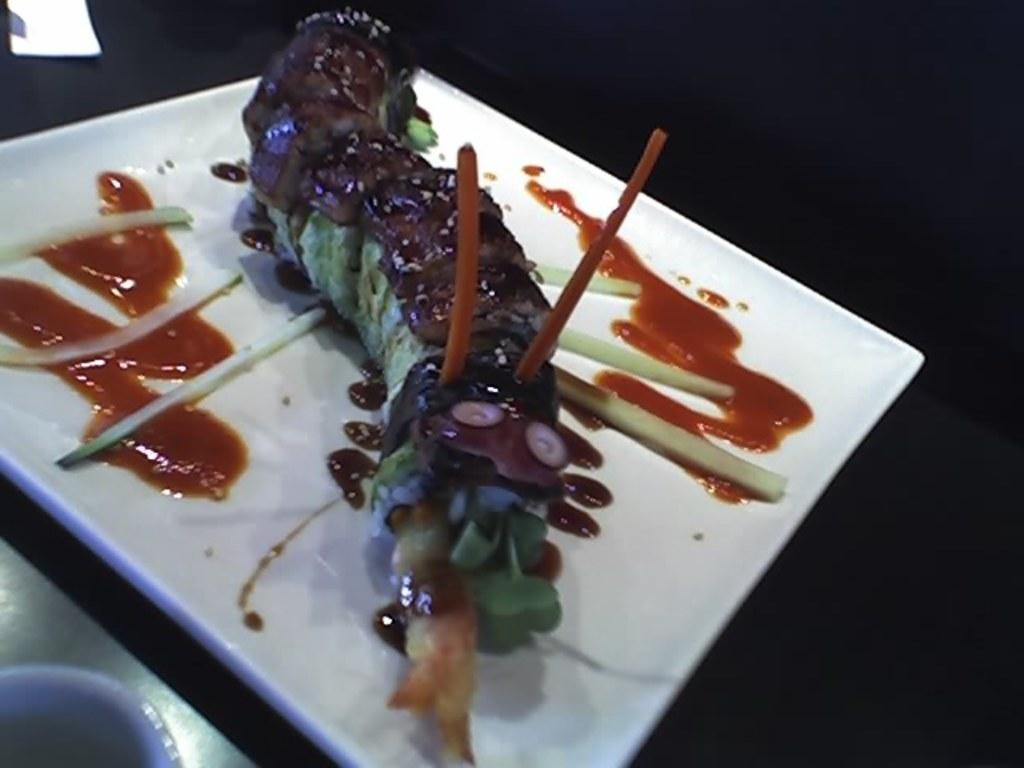What is on the plate that is visible in the image? There is a food item on a plate in the image. Where is the plate located in the image? The plate is placed on a table in the image. What type of treatment is being administered to the food item in the image? There is no treatment being administered to the food item in the image; it is simply a food item on a plate. 